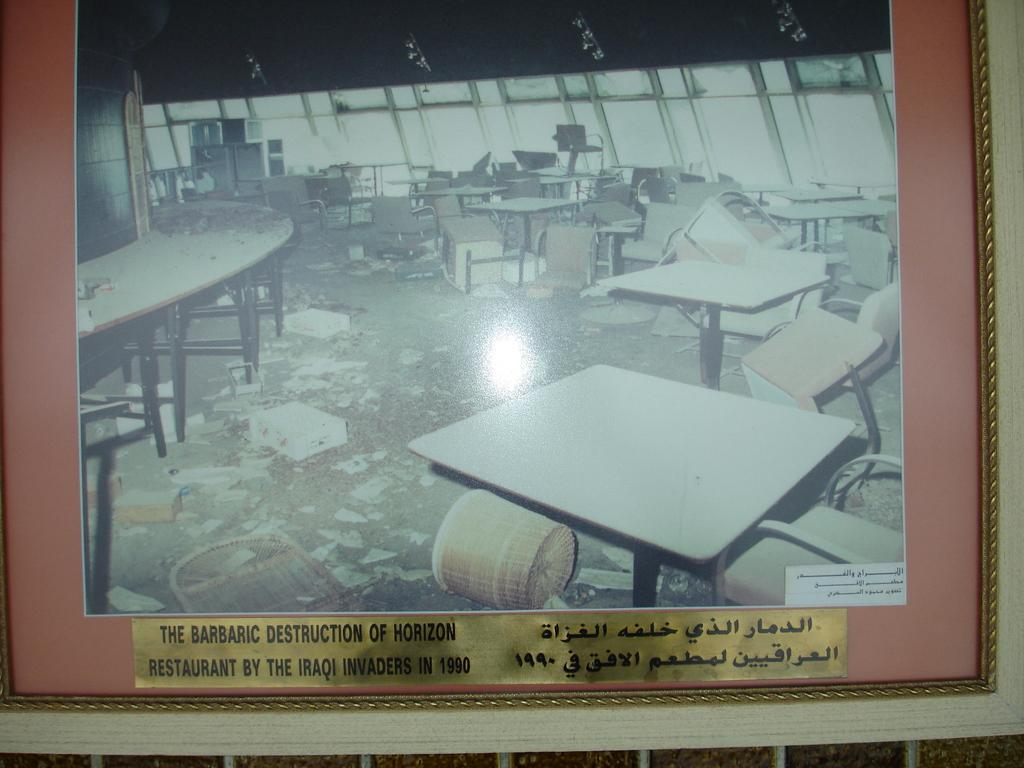What type of furniture is present in the image? There are tables and chairs in the image. What other object can be seen in the image? There is a basket in the image. How many pizzas are being served on the tables in the image? There is no information about pizzas in the image, as the facts only mention tables, chairs, and a basket. 